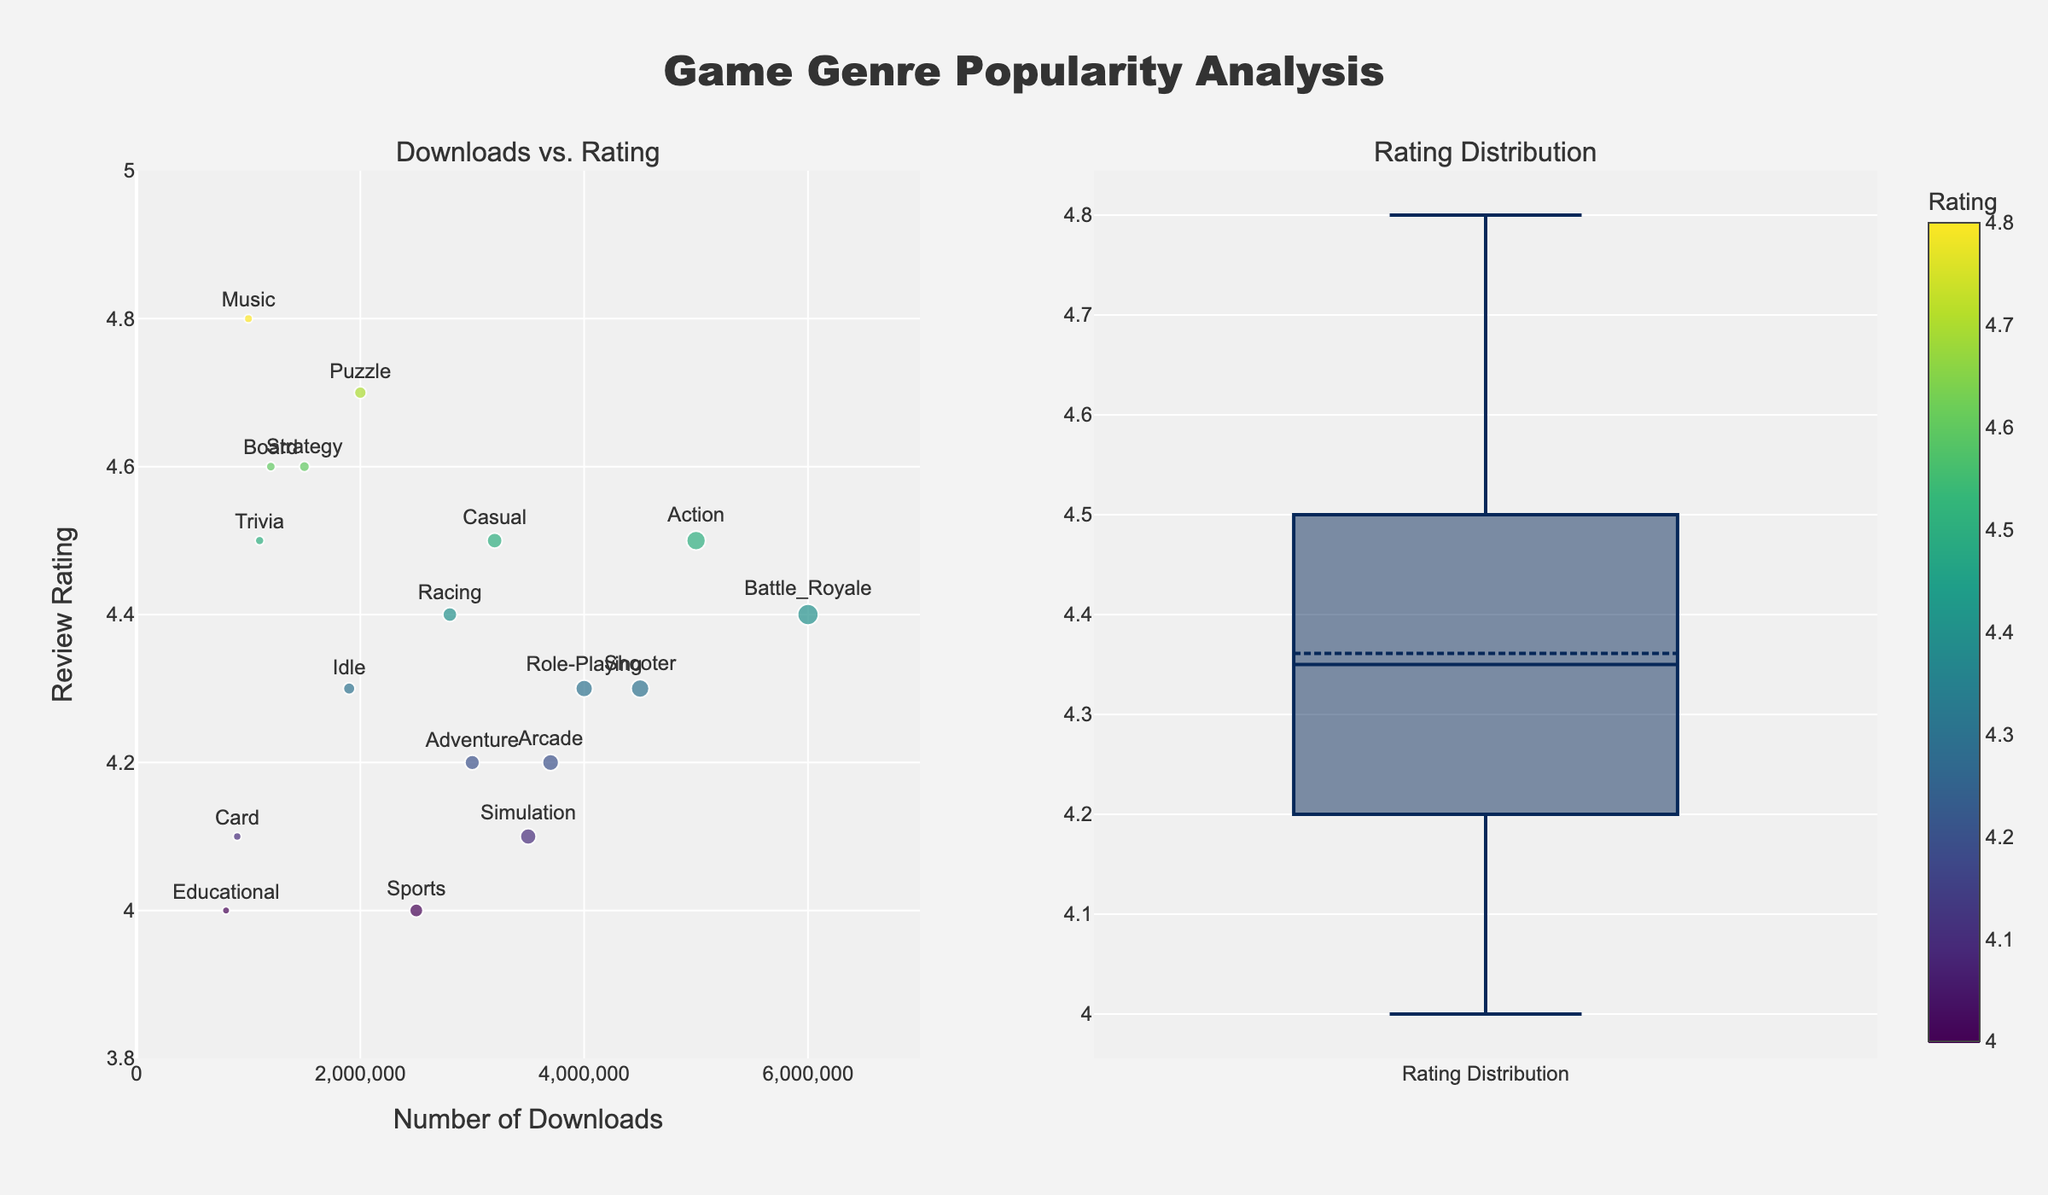What's the title of the plot? The plot title is displayed at the top center of the figure. It reads "Game Genre Popularity Analysis".
Answer: Game Genre Popularity Analysis What is the range of the y-axis in the scatter plot? The y-axis range is indicated on the left side of the scatter plot. It spans from 3.8 to 5.0.
Answer: 3.8 to 5.0 Which game genre has the highest number of downloads and what is its review rating? By looking at the scatter plot, the marker for "Battle_Royale" is the furthest to the right, representing the highest number of downloads, which is 6,000,000. The review rating for "Battle_Royale" is shown just above the marker, which is 4.4.
Answer: Battle_Royale, 4.4 How is the size of each marker determined in the scatter plot? The size of each marker is determined by the number of downloads. The larger the number of downloads, the larger the marker size. This can be inferred from the varying marker sizes and the provided code comment.
Answer: By the number of downloads Which game genre has the highest review rating and what is the number of downloads for it? According to the scatter plot, the game genre "Music" has the highest review rating, which is 4.8. From the marker's position, we can see it has 1,000,000 downloads.
Answer: Music, 1,000,000 What is the median review rating from the box plot? The median review rating can be determined from the box plot where the line inside the box represents the median value. It is approximately at 4.4.
Answer: 4.4 How many game genres have review ratings of 4.5 or higher? Observing the scatter plot and counting the markers with y-values 4.5 or higher, we see "Action," "Puzzle," "Strategy," "Casual," "Music," and "Trivia," making a total of 6 game genres.
Answer: 6 Which two game genres have the closest review ratings but a noticeable difference in the number of downloads? By examining both scatter plot and text annotations, "Shooter" and "Role-Playing" both have a review rating of 4.3. However, "Shooter" has 4,500,000 downloads, and "Role-Playing" has 4,000,000 downloads.
Answer: Shooter and Role-Playing What is the average review rating of genres with more than 3,000,000 downloads? Genres with more than 3,000,000 downloads: "Action", "Adventure", "Role-Playing", "Simulation", "Shooter", "Casual", "Arcade", "Battle_Royale". Their ratings: 4.5, 4.2, 4.3, 4.1, 4.3, 4.5, 4.2, 4.4. Average rating: (4.5 + 4.2 + 4.3 + 4.1 + 4.3 + 4.5 + 4.2 + 4.4) / 8 = 4.3125.
Answer: 4.3 Which game genre has the lowest number of downloads and what is the review rating for it? The marker for "Educational" is the furthest left in the scatter plot, indicating the lowest number of downloads, which is 800,000. The review rating for "Educational" is shown above the marker, which is 4.0.
Answer: Educational, 4.0 